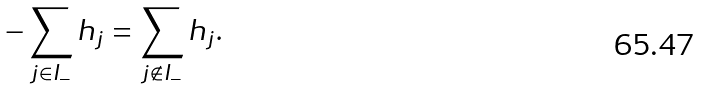Convert formula to latex. <formula><loc_0><loc_0><loc_500><loc_500>- \sum _ { j \in I _ { - } } h _ { j } = \sum _ { j \notin I _ { - } } h _ { j } .</formula> 